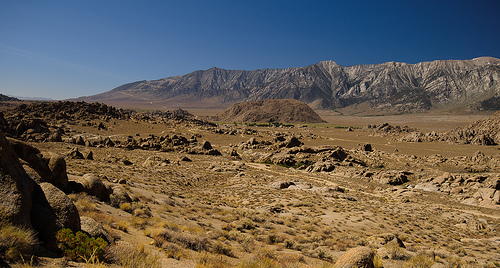<image>
Is the mountain in front of the sky? Yes. The mountain is positioned in front of the sky, appearing closer to the camera viewpoint. 